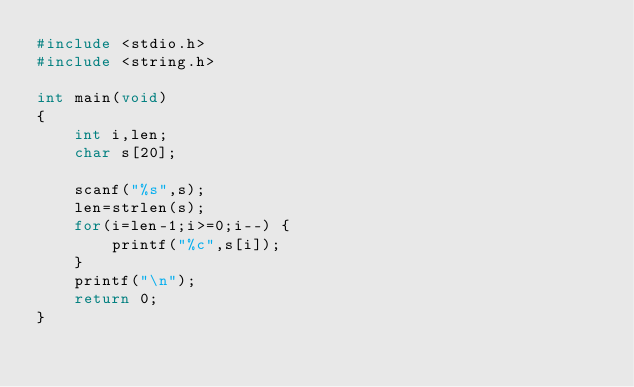<code> <loc_0><loc_0><loc_500><loc_500><_C_>#include <stdio.h>
#include <string.h>

int main(void)
{
	int i,len;
	char s[20];

	scanf("%s",s);
	len=strlen(s);
	for(i=len-1;i>=0;i--) {
		printf("%c",s[i]);
	}
	printf("\n");
	return 0;
}</code> 